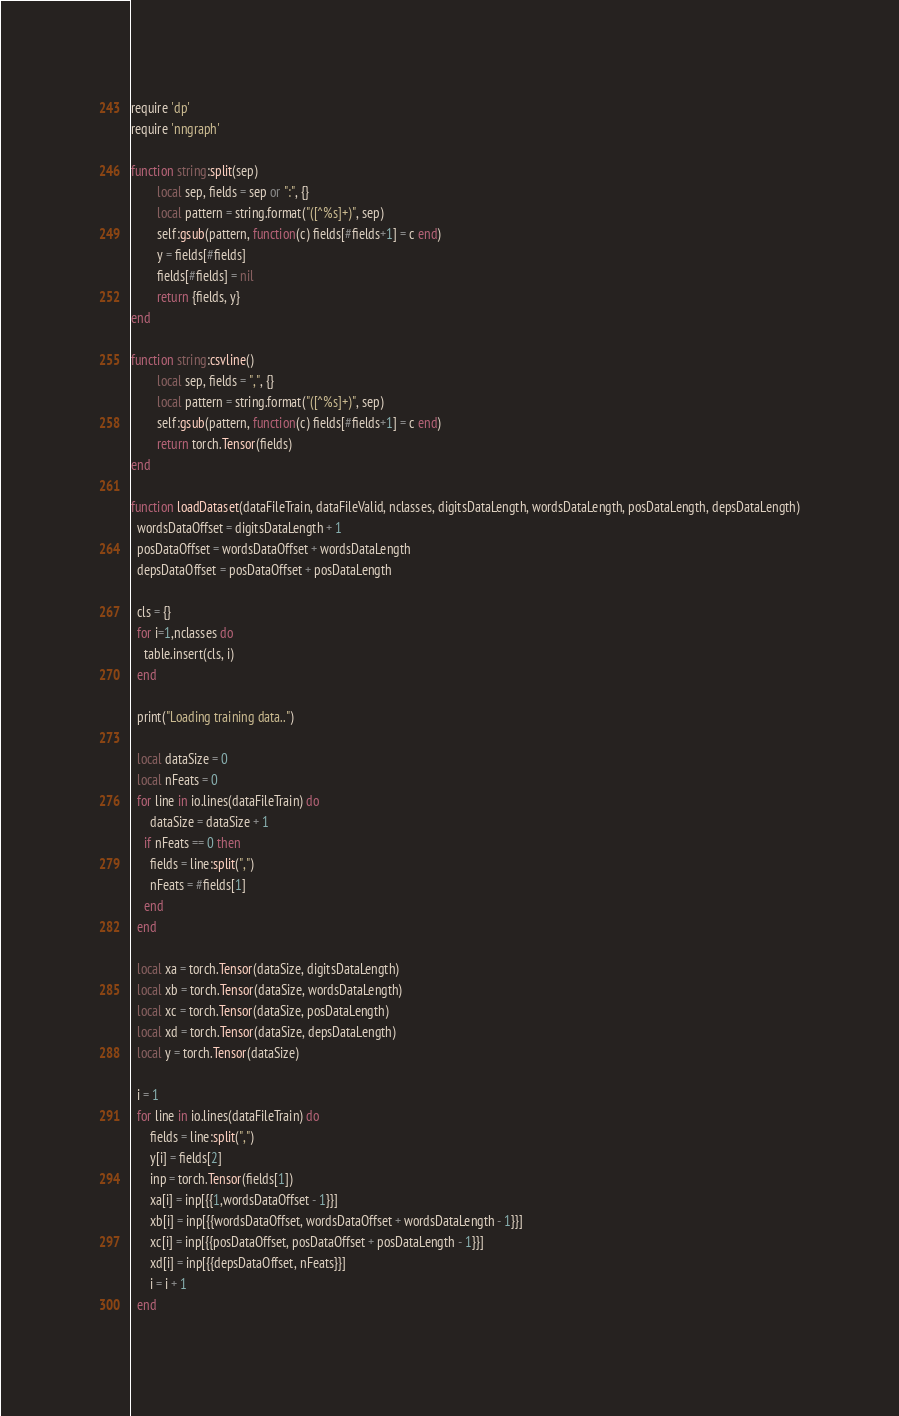<code> <loc_0><loc_0><loc_500><loc_500><_Lua_>require 'dp'
require 'nngraph'

function string:split(sep)
        local sep, fields = sep or ":", {}
        local pattern = string.format("([^%s]+)", sep)
        self:gsub(pattern, function(c) fields[#fields+1] = c end)
        y = fields[#fields]
        fields[#fields] = nil
        return {fields, y}
end

function string:csvline()
        local sep, fields = ",", {}
        local pattern = string.format("([^%s]+)", sep)
        self:gsub(pattern, function(c) fields[#fields+1] = c end)
        return torch.Tensor(fields)
end

function loadDataset(dataFileTrain, dataFileValid, nclasses, digitsDataLength, wordsDataLength, posDataLength, depsDataLength)
  wordsDataOffset = digitsDataLength + 1
  posDataOffset = wordsDataOffset + wordsDataLength
  depsDataOffset = posDataOffset + posDataLength

  cls = {}
  for i=1,nclasses do
    table.insert(cls, i)
  end

  print("Loading training data..")

  local dataSize = 0
  local nFeats = 0
  for line in io.lines(dataFileTrain) do
      dataSize = dataSize + 1
    if nFeats == 0 then
      fields = line:split(",")
      nFeats = #fields[1]
    end
  end

  local xa = torch.Tensor(dataSize, digitsDataLength)
  local xb = torch.Tensor(dataSize, wordsDataLength)
  local xc = torch.Tensor(dataSize, posDataLength)
  local xd = torch.Tensor(dataSize, depsDataLength)
  local y = torch.Tensor(dataSize)

  i = 1
  for line in io.lines(dataFileTrain) do
      fields = line:split(",")
      y[i] = fields[2]
      inp = torch.Tensor(fields[1])
      xa[i] = inp[{{1,wordsDataOffset - 1}}]
      xb[i] = inp[{{wordsDataOffset, wordsDataOffset + wordsDataLength - 1}}]
      xc[i] = inp[{{posDataOffset, posDataOffset + posDataLength - 1}}]
      xd[i] = inp[{{depsDataOffset, nFeats}}]
      i = i + 1
  end</code> 